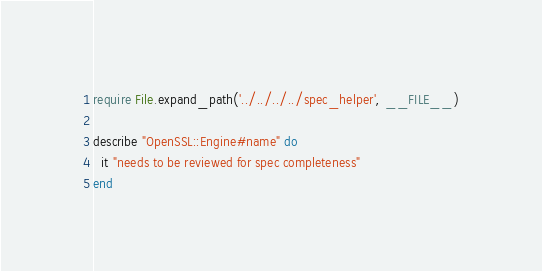Convert code to text. <code><loc_0><loc_0><loc_500><loc_500><_Ruby_>require File.expand_path('../../../../spec_helper', __FILE__)

describe "OpenSSL::Engine#name" do
  it "needs to be reviewed for spec completeness"
end
</code> 